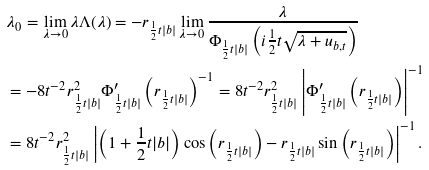Convert formula to latex. <formula><loc_0><loc_0><loc_500><loc_500>& \lambda _ { 0 } = \lim _ { \lambda \rightarrow 0 } \lambda \Lambda ( \lambda ) = - r _ { \frac { 1 } { 2 } t | b | } \lim _ { \lambda \rightarrow 0 } \frac { \lambda } { \Phi _ { \frac { 1 } { 2 } t | b | } \left ( i \frac { 1 } { 2 } t \sqrt { \lambda + u _ { b , t } } \right ) } \\ & = - 8 t ^ { - 2 } r ^ { 2 } _ { \frac { 1 } { 2 } t | b | } \Phi ^ { \prime } _ { \frac { 1 } { 2 } t | b | } \left ( r _ { \frac { 1 } { 2 } t | b | } \right ) ^ { - 1 } = 8 t ^ { - 2 } r ^ { 2 } _ { \frac { 1 } { 2 } t | b | } \left | \Phi ^ { \prime } _ { \frac { 1 } { 2 } t | b | } \left ( r _ { \frac { 1 } { 2 } t | b | } \right ) \right | ^ { - 1 } \\ & = 8 t ^ { - 2 } r ^ { 2 } _ { \frac { 1 } { 2 } t | b | } \left | \left ( 1 + \frac { 1 } { 2 } t | b | \right ) \cos \left ( r _ { \frac { 1 } { 2 } t | b | } \right ) - r _ { \frac { 1 } { 2 } t | b | } \sin \left ( r _ { \frac { 1 } { 2 } t | b | } \right ) \right | ^ { - 1 } .</formula> 